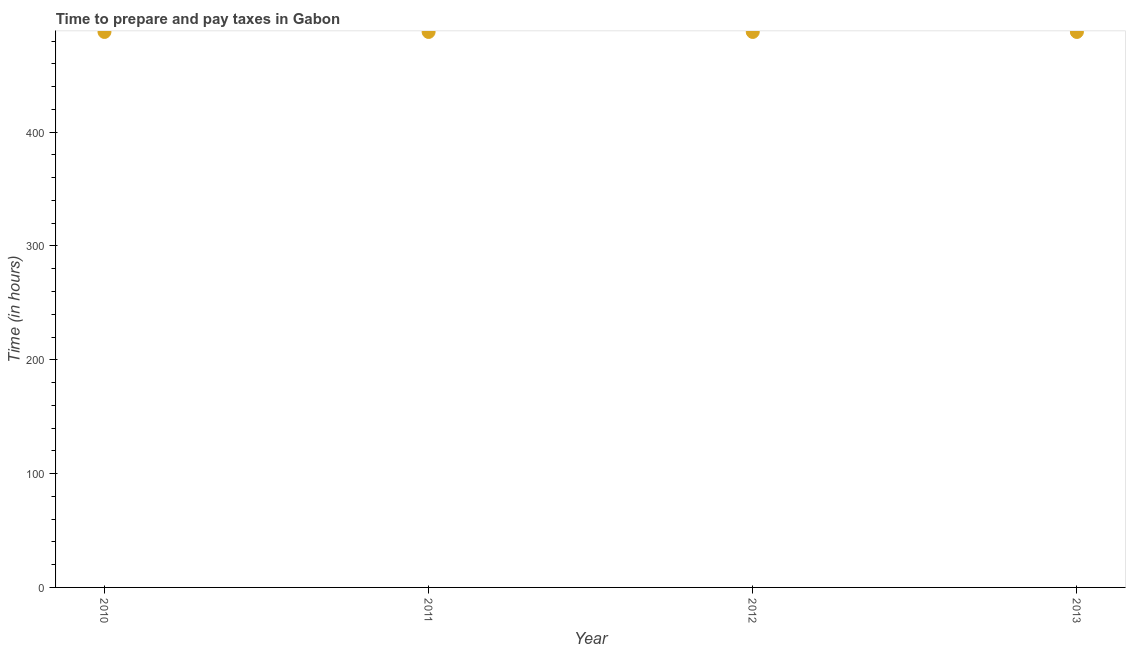What is the time to prepare and pay taxes in 2013?
Offer a terse response. 488. Across all years, what is the maximum time to prepare and pay taxes?
Ensure brevity in your answer.  488. Across all years, what is the minimum time to prepare and pay taxes?
Give a very brief answer. 488. In which year was the time to prepare and pay taxes minimum?
Provide a short and direct response. 2010. What is the sum of the time to prepare and pay taxes?
Your answer should be very brief. 1952. What is the difference between the time to prepare and pay taxes in 2010 and 2012?
Ensure brevity in your answer.  0. What is the average time to prepare and pay taxes per year?
Your answer should be compact. 488. What is the median time to prepare and pay taxes?
Offer a very short reply. 488. In how many years, is the time to prepare and pay taxes greater than 120 hours?
Ensure brevity in your answer.  4. What is the ratio of the time to prepare and pay taxes in 2010 to that in 2012?
Your answer should be compact. 1. What is the difference between the highest and the lowest time to prepare and pay taxes?
Keep it short and to the point. 0. In how many years, is the time to prepare and pay taxes greater than the average time to prepare and pay taxes taken over all years?
Your response must be concise. 0. How many years are there in the graph?
Your answer should be very brief. 4. What is the difference between two consecutive major ticks on the Y-axis?
Your answer should be very brief. 100. Does the graph contain any zero values?
Ensure brevity in your answer.  No. What is the title of the graph?
Ensure brevity in your answer.  Time to prepare and pay taxes in Gabon. What is the label or title of the X-axis?
Your response must be concise. Year. What is the label or title of the Y-axis?
Ensure brevity in your answer.  Time (in hours). What is the Time (in hours) in 2010?
Offer a very short reply. 488. What is the Time (in hours) in 2011?
Offer a very short reply. 488. What is the Time (in hours) in 2012?
Your answer should be compact. 488. What is the Time (in hours) in 2013?
Provide a succinct answer. 488. What is the difference between the Time (in hours) in 2010 and 2011?
Offer a very short reply. 0. What is the difference between the Time (in hours) in 2010 and 2012?
Provide a succinct answer. 0. What is the difference between the Time (in hours) in 2010 and 2013?
Your answer should be compact. 0. What is the difference between the Time (in hours) in 2012 and 2013?
Provide a short and direct response. 0. What is the ratio of the Time (in hours) in 2010 to that in 2012?
Offer a very short reply. 1. What is the ratio of the Time (in hours) in 2010 to that in 2013?
Your answer should be compact. 1. What is the ratio of the Time (in hours) in 2011 to that in 2012?
Provide a short and direct response. 1. 